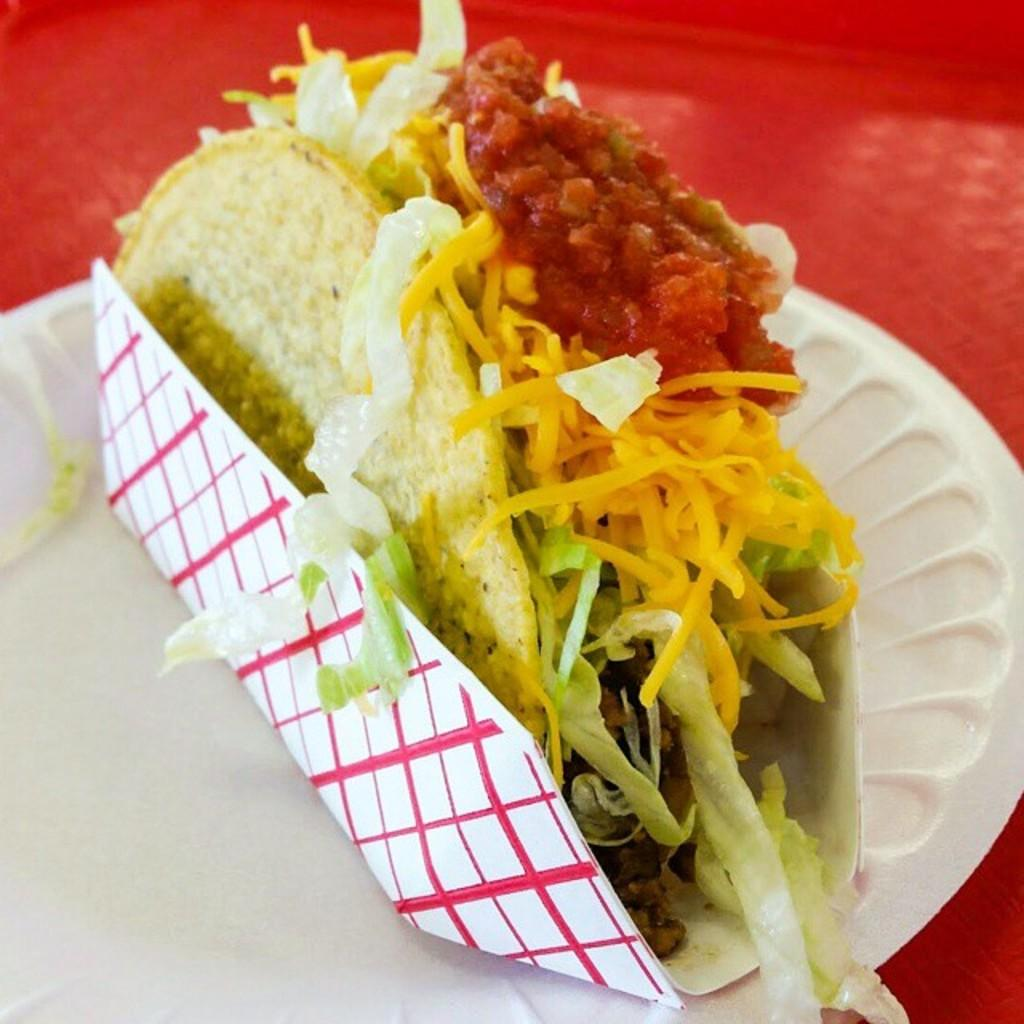What is the main subject of the image? There is an eatable item in the image. How is the eatable item positioned in the image? The eatable item is placed on a paper. How many steps are required to reach the fork in the image? There is no fork present in the image. What type of beam is supporting the eatable item in the image? There is no beam present in the image; the eatable item is placed on a paper. 